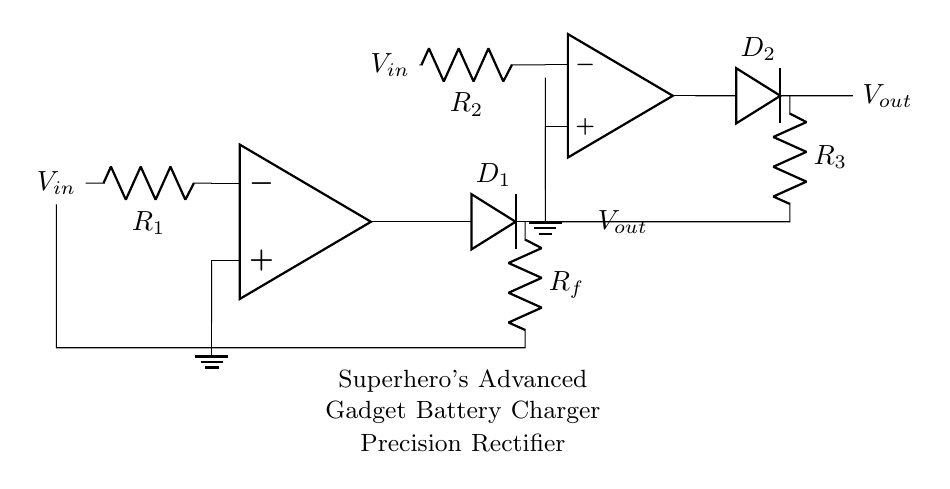What are the main components in this circuit? The circuit consists of two operational amplifiers, two diodes, and three resistors. These components work together to create the precision rectifier function.
Answer: operational amplifiers, diodes, resistors What is the purpose of the diodes in this circuit? The diodes conduct current only in one direction, allowing for the rectification of the input voltage by filtering out the negative portions of the signal.
Answer: rectification How many resistors are there in total? There are three resistors in the circuit, labeled R1, R2, and R3, connected to different parts of the operational amplifiers and diodes.
Answer: three What is the function of the operational amplifiers? The operational amplifiers amplify the input signal and provide the necessary gain to ensure that the rectified output voltage accurately follows the input voltage during positive cycles.
Answer: amplification How do the resistors affect the circuit's performance? The values of the resistors (R1, R2, R3) influence the gain and response time of the operational amplifiers, which in turn affects the overall accuracy and speed of the rectification process.
Answer: gain and response time What type of rectifier is represented in this circuit? This circuit is a precision rectifier, also known as a super diode, which allows for accurate rectification of small input signals that traditional diode rectifiers may not handle effectively.
Answer: precision rectifier How does the feedback loop function in this circuit? The feedback loop, formed by Rf and the connections to the output of the op-amps, maintains stability and ensures that the output voltage closely follows the input voltage during the rectification process.
Answer: maintains stability 